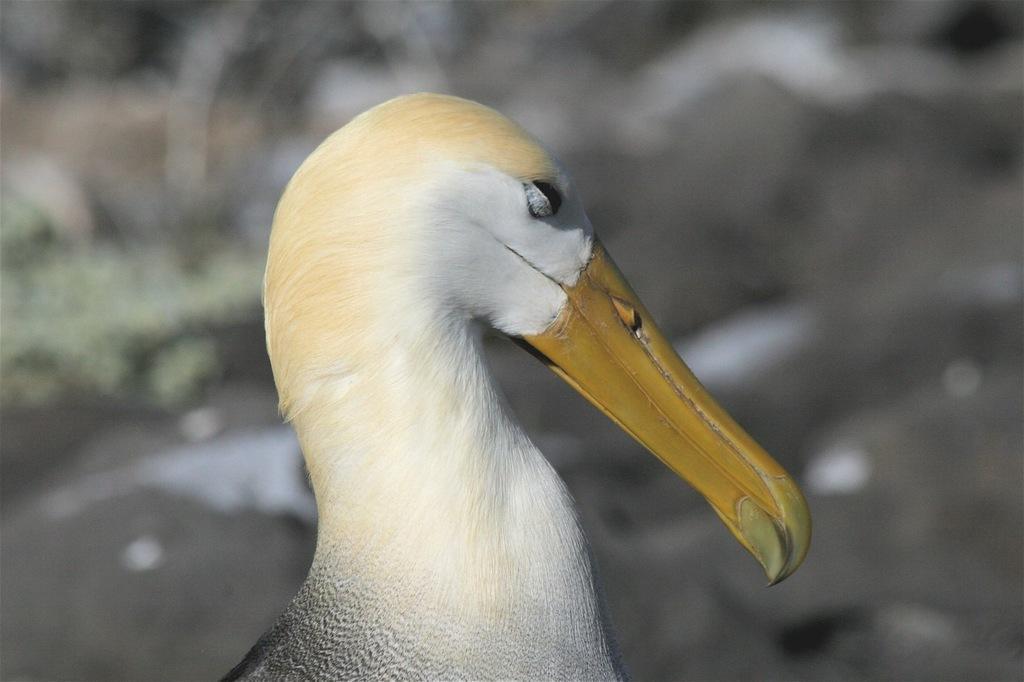Please provide a concise description of this image. This image is taken outdoors. In this image the background is blurred and it is gray in color. In the middle of the image there is a bird with long beak. 